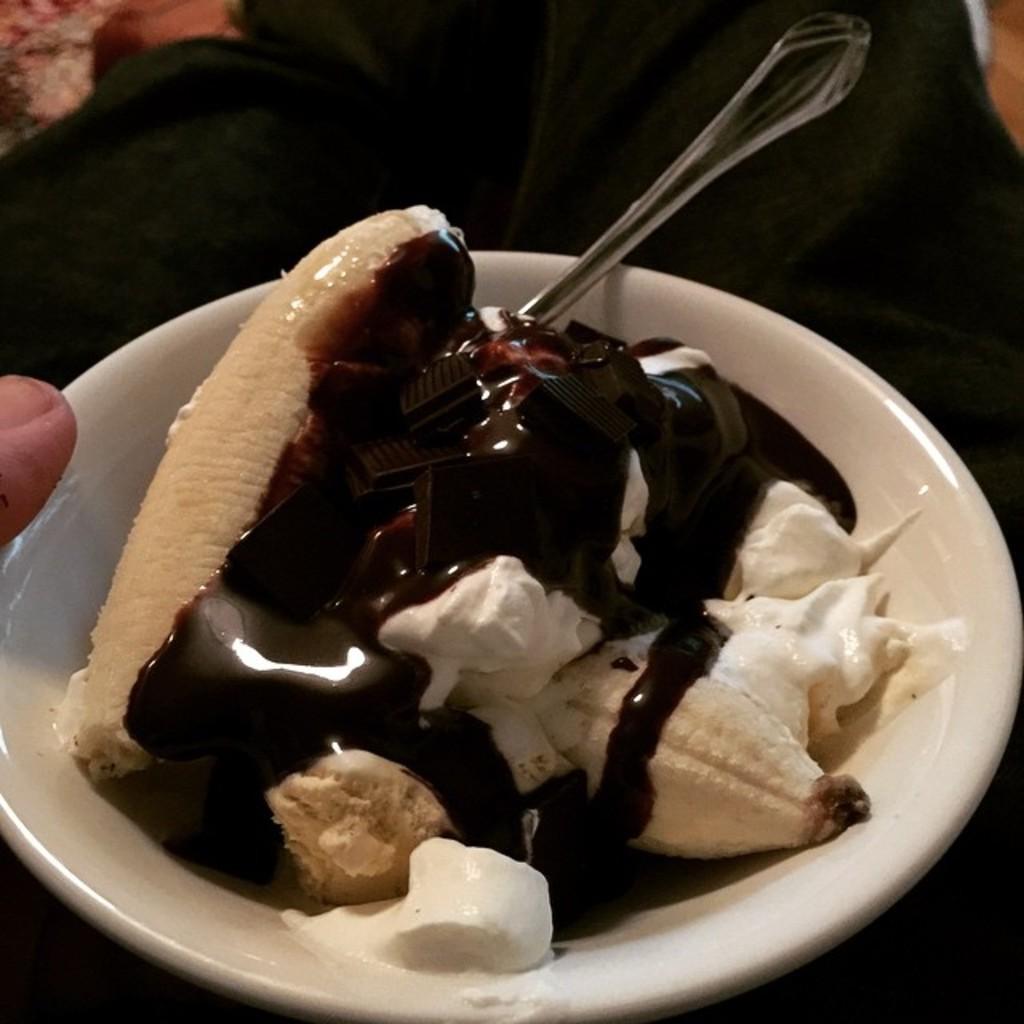In one or two sentences, can you explain what this image depicts? Here we can see a bowl, spoon, and food. There is a dark background. 